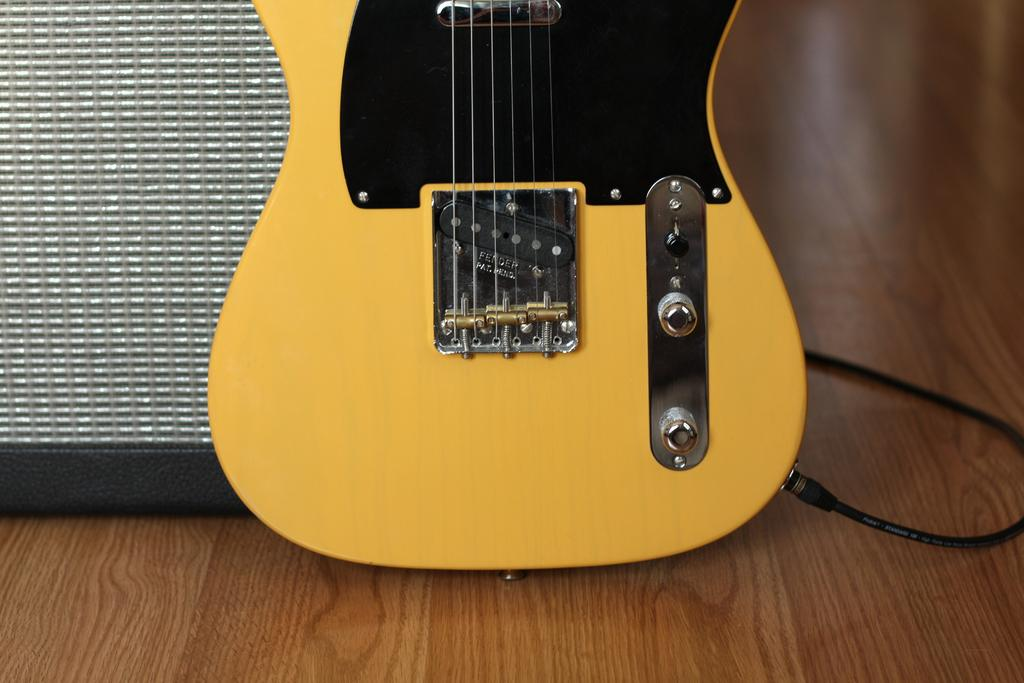What musical instrument is on the wooden floor in the image? There is a guitar on the wooden floor in the image. What can be seen on the right side of the image? There is a black color cable on the right side of the image. What object is on the left side of the image? There is a box on the left side of the image. What reason does the mom have for being disgusted in the image? There is no mom or any indication of disgust in the image. 